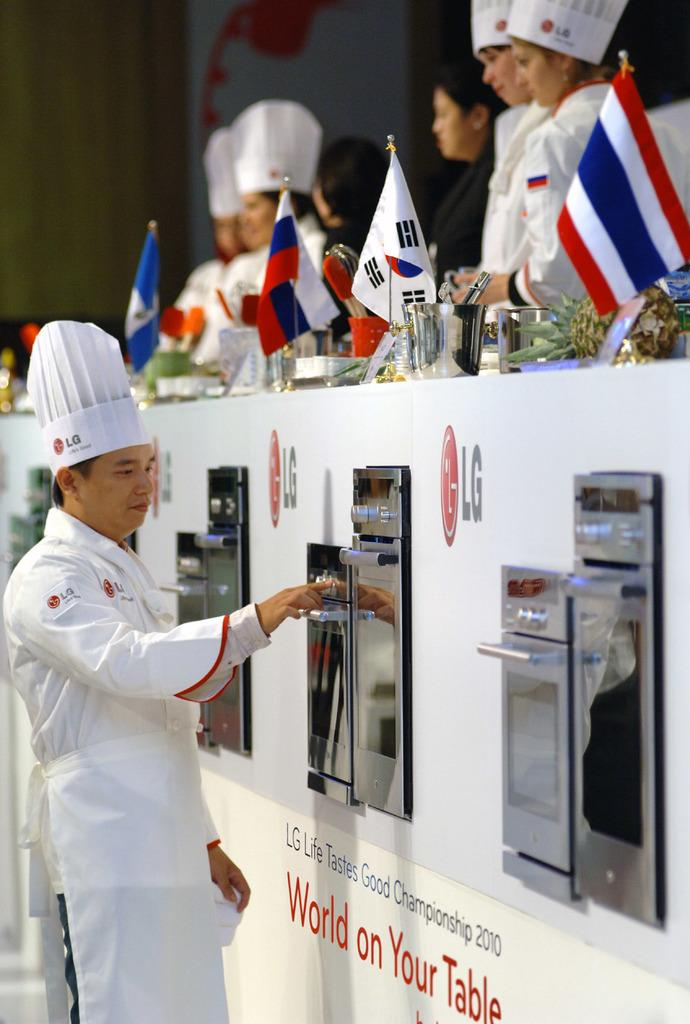<image>
Provide a brief description of the given image. Several people are at he LG Life Tastes Good Championship in 2010. 